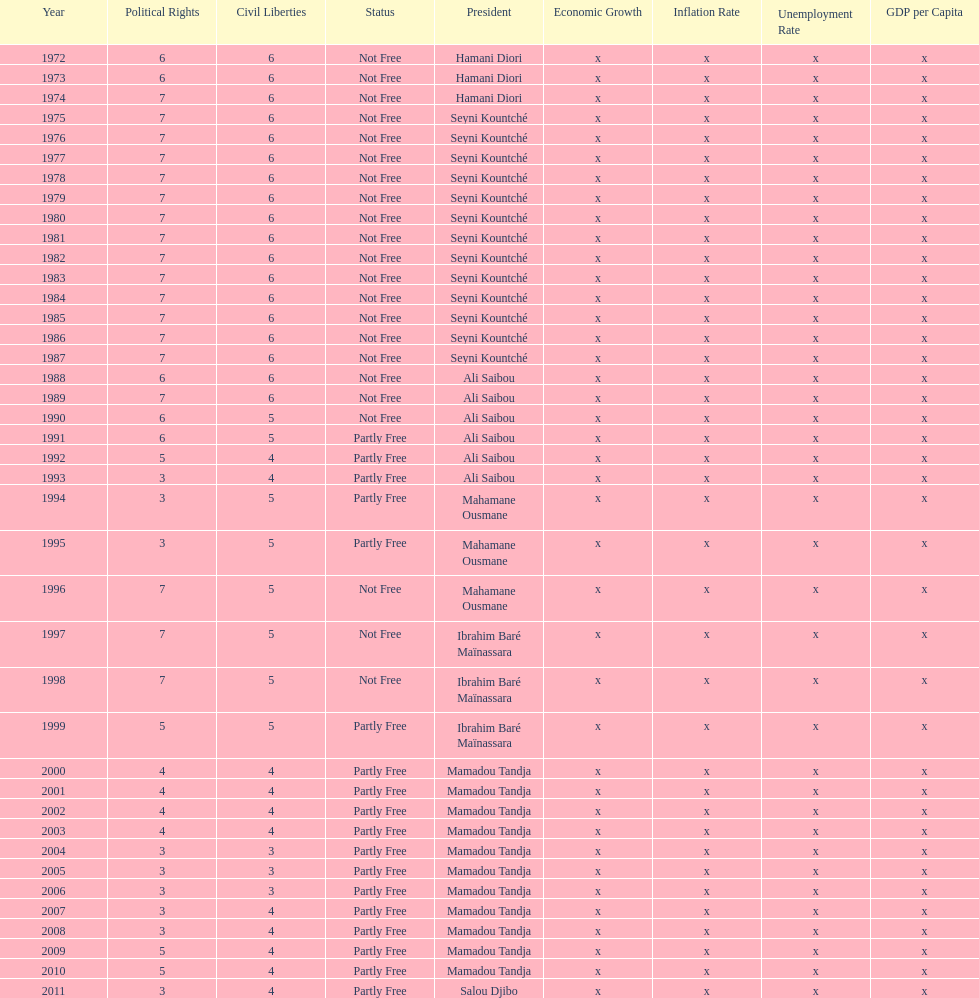Who ruled longer, ali saibou or mamadou tandja? Mamadou Tandja. 